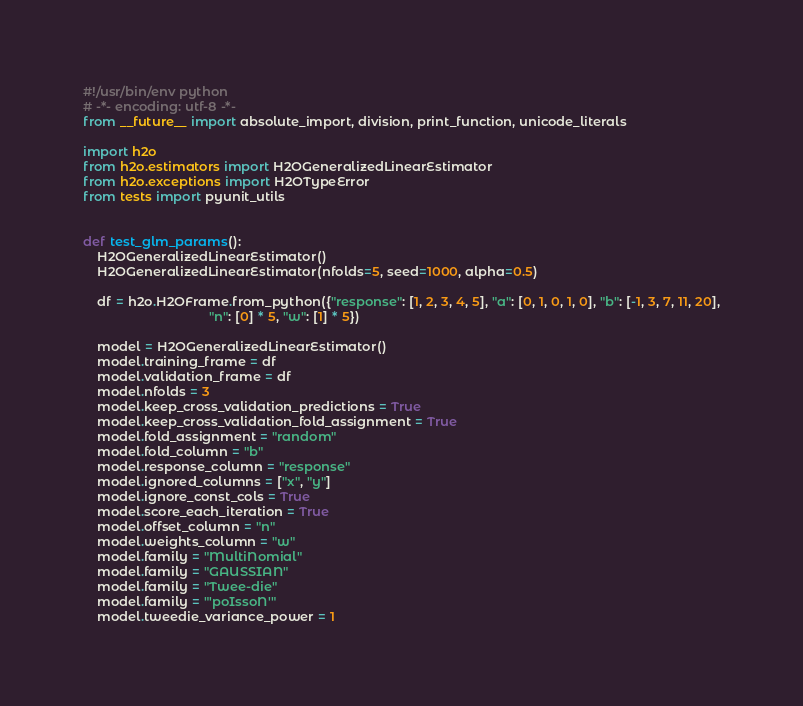<code> <loc_0><loc_0><loc_500><loc_500><_Python_>#!/usr/bin/env python
# -*- encoding: utf-8 -*-
from __future__ import absolute_import, division, print_function, unicode_literals

import h2o
from h2o.estimators import H2OGeneralizedLinearEstimator
from h2o.exceptions import H2OTypeError
from tests import pyunit_utils


def test_glm_params():
    H2OGeneralizedLinearEstimator()
    H2OGeneralizedLinearEstimator(nfolds=5, seed=1000, alpha=0.5)

    df = h2o.H2OFrame.from_python({"response": [1, 2, 3, 4, 5], "a": [0, 1, 0, 1, 0], "b": [-1, 3, 7, 11, 20],
                                   "n": [0] * 5, "w": [1] * 5})

    model = H2OGeneralizedLinearEstimator()
    model.training_frame = df
    model.validation_frame = df
    model.nfolds = 3
    model.keep_cross_validation_predictions = True
    model.keep_cross_validation_fold_assignment = True
    model.fold_assignment = "random"
    model.fold_column = "b"
    model.response_column = "response"
    model.ignored_columns = ["x", "y"]
    model.ignore_const_cols = True
    model.score_each_iteration = True
    model.offset_column = "n"
    model.weights_column = "w"
    model.family = "MultiNomial"
    model.family = "GAUSSIAN"
    model.family = "Twee-die"
    model.family = "'poIssoN'"
    model.tweedie_variance_power = 1</code> 